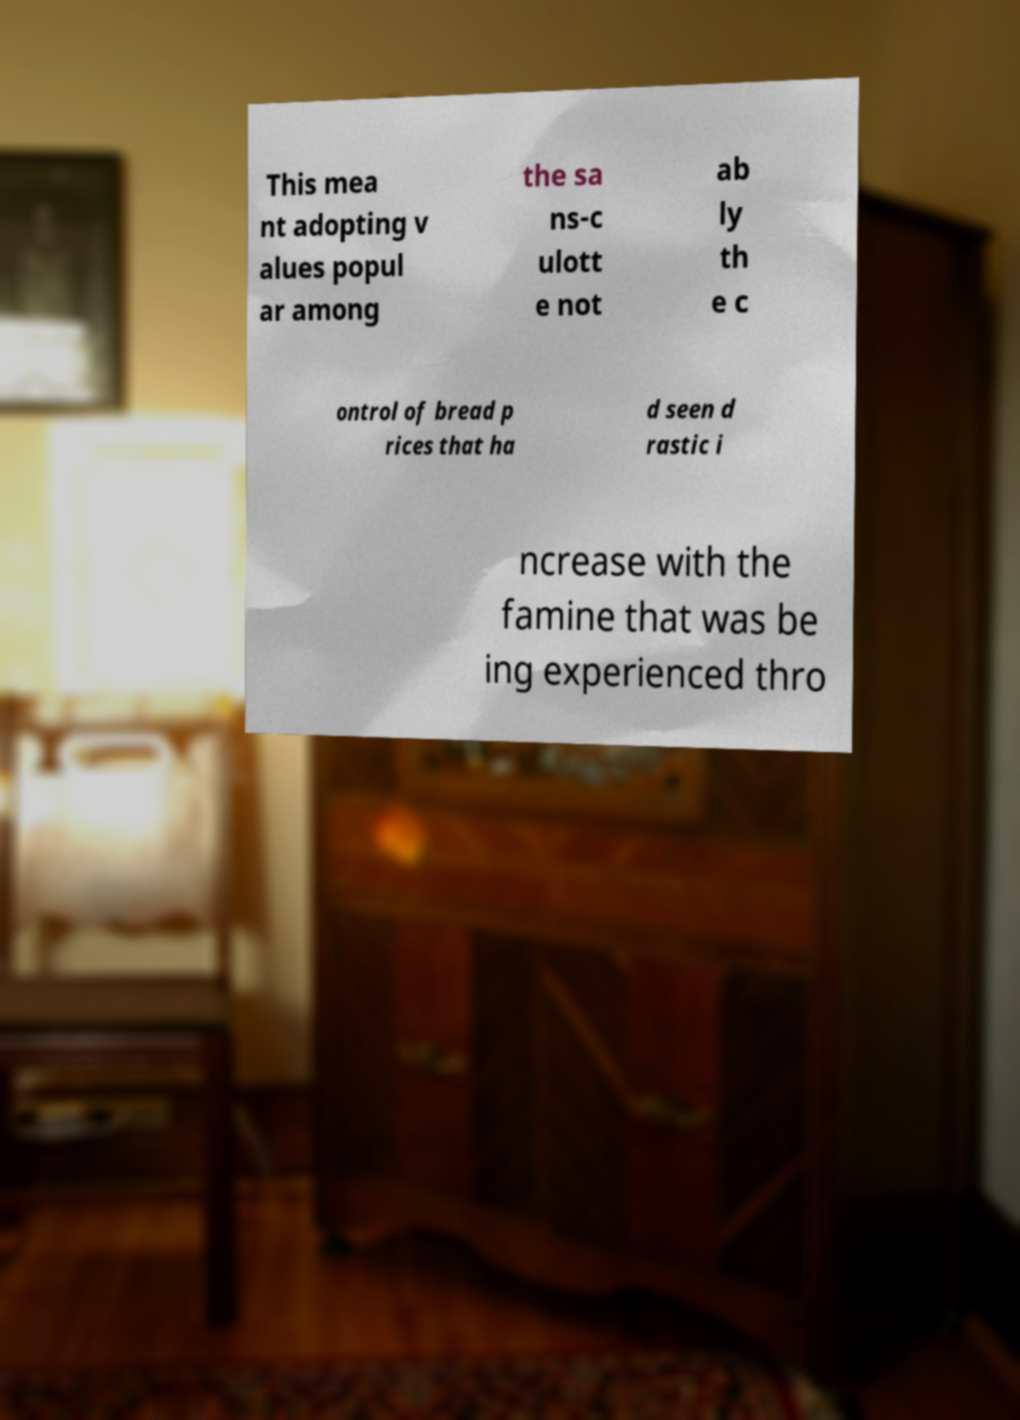Please read and relay the text visible in this image. What does it say? This mea nt adopting v alues popul ar among the sa ns-c ulott e not ab ly th e c ontrol of bread p rices that ha d seen d rastic i ncrease with the famine that was be ing experienced thro 